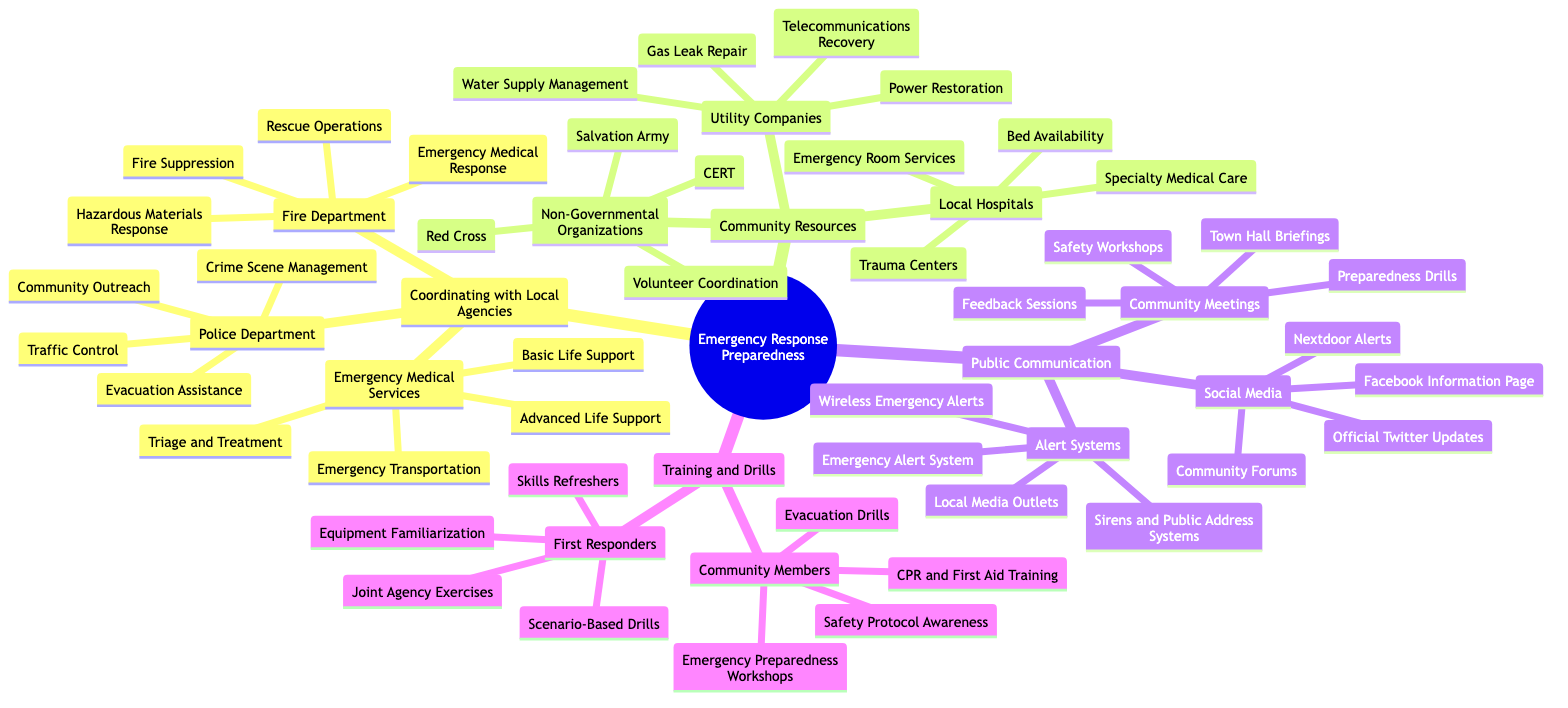What are the four key functions of the Fire Department? The diagram shows four key functions under the Fire Department node: Fire Suppression, Rescue Operations, Emergency Medical Response, and Hazardous Materials Response.
Answer: Fire Suppression, Rescue Operations, Emergency Medical Response, Hazardous Materials Response How many different local agencies are coordinated for emergency response? The diagram illustrates three main local agencies: Fire Department, Police Department, and Emergency Medical Services. Therefore, the total number of local agencies is three.
Answer: three What services does the Police Department provide in emergencies? The diagram lists four services provided by the Police Department: Crime Scene Management, Traffic Control, Evacuation Assistance, and Community Outreach.
Answer: Crime Scene Management, Traffic Control, Evacuation Assistance, Community Outreach Which section includes community training for members? The diagram indicates that community training for members is included in the Training and Drills section, specifically under Community Members.
Answer: Training and Drills How many categories of Public Communication are listed in the diagram? The diagram contains three categories of Public Communication: Alert Systems, Community Meetings, and Social Media. Hence, the total number of categories is three.
Answer: three What organization is listed first under Non-Governmental Organizations? The diagram shows the Red Cross listed first among the Non-Governmental Organizations.
Answer: Red Cross What is the primary role of Emergency Medical Services in emergencies? The diagram outlines four primary roles for Emergency Medical Services, including Advanced Life Support and Emergency Transportation, indicating their critical role in providing medical assistance.
Answer: Advanced Life Support, Emergency Transportation How does the diagram categorize Emergency Response Preparedness? The diagram categorizes Emergency Response Preparedness into four main areas: Coordinating with Local Agencies, Community Resources, Public Communication, and Training and Drills.
Answer: Coordinating with Local Agencies, Community Resources, Public Communication, Training and Drills What type of alert system is included under Public Communication? The diagram identifies Emergency Alert System as one of the alert systems included under Public Communication.
Answer: Emergency Alert System 